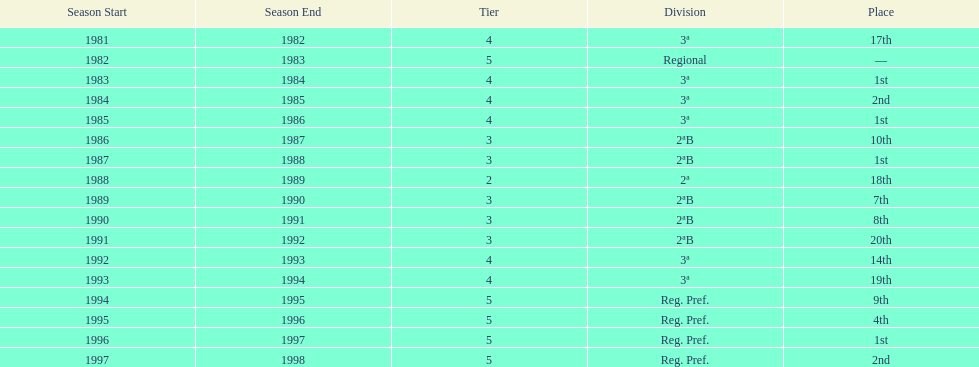Which tier was ud alzira a part of the least? 2. 